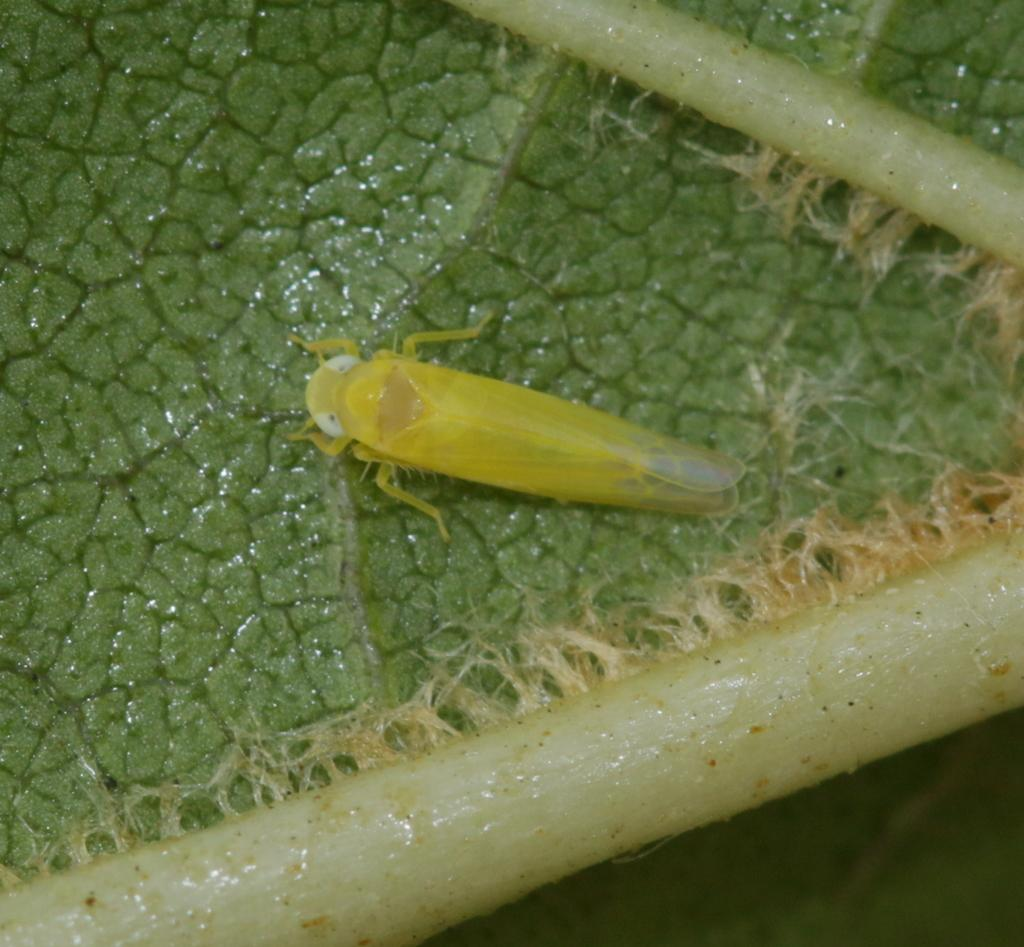What color is the surface visible in the image? The surface in the image is green. What type of living organism can be seen on the green surface? There is an insect on the green surface. Where is the zebra located in the image? There is no zebra present in the image. Is the insect in jail in the image? There is no jail or any indication of confinement in the image; it simply shows an insect on a green surface. 